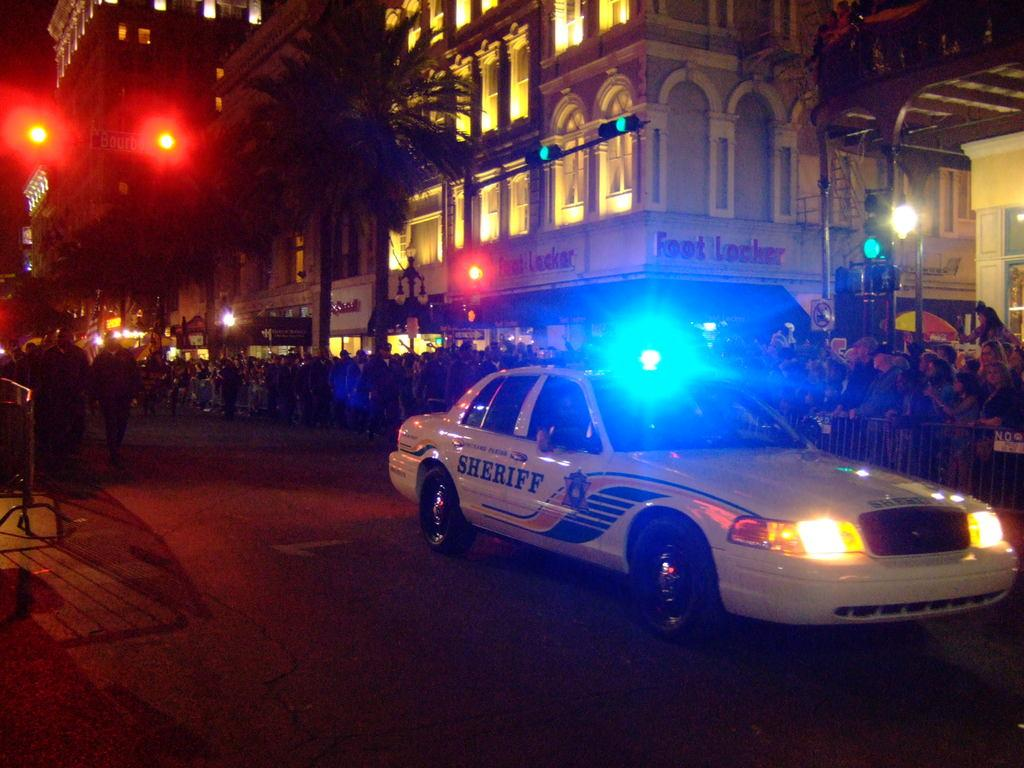What is the main subject of the image? The main subject of the image is a car on the road. What can be seen behind the car? There are groups of people behind the car. What objects are present to control traffic in the image? There are poles with traffic lights in the image. What type of natural elements can be seen in the image? Trees are visible in the image. What type of man-made structures are present in the image? Buildings are present in the image. What type of pies are being served at the historical event in the image? There is no mention of pies or a historical event in the image; it features a car on the road with groups of people, barricades, trees, buildings, and traffic lights. 